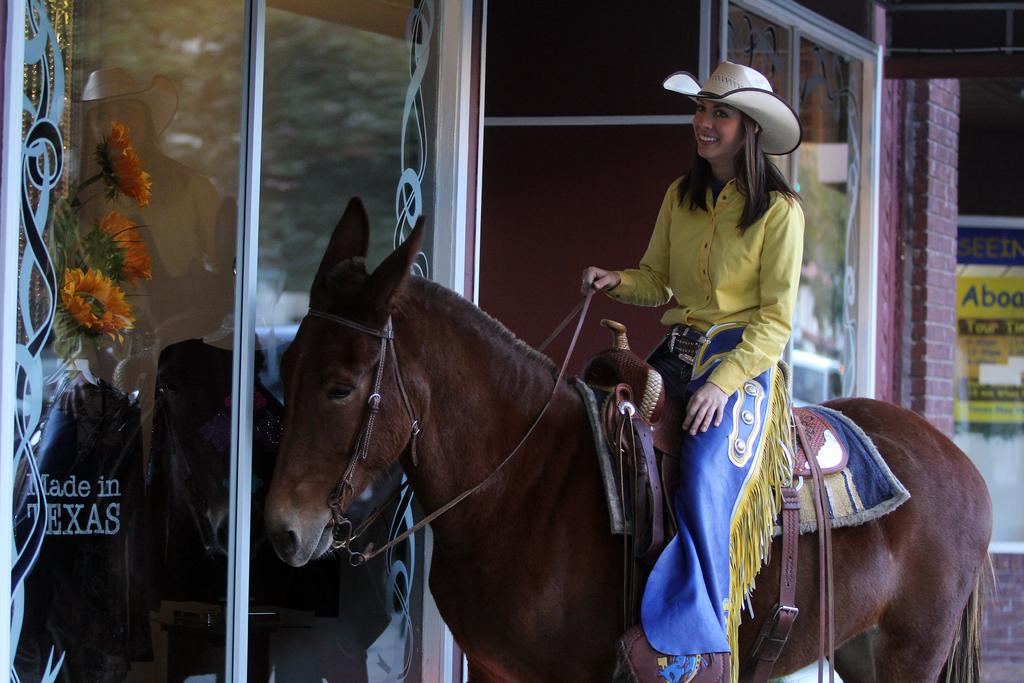What is the woman doing in the image? The woman is sitting on a horse in the image. What can be seen in the background of the image? There is a building and a poster with text in the background. What type of decoration is present in the room? There are flowers in the room. What type of border can be seen around the flowers in the image? There is no border around the flowers in the image; they are simply present in the room. 